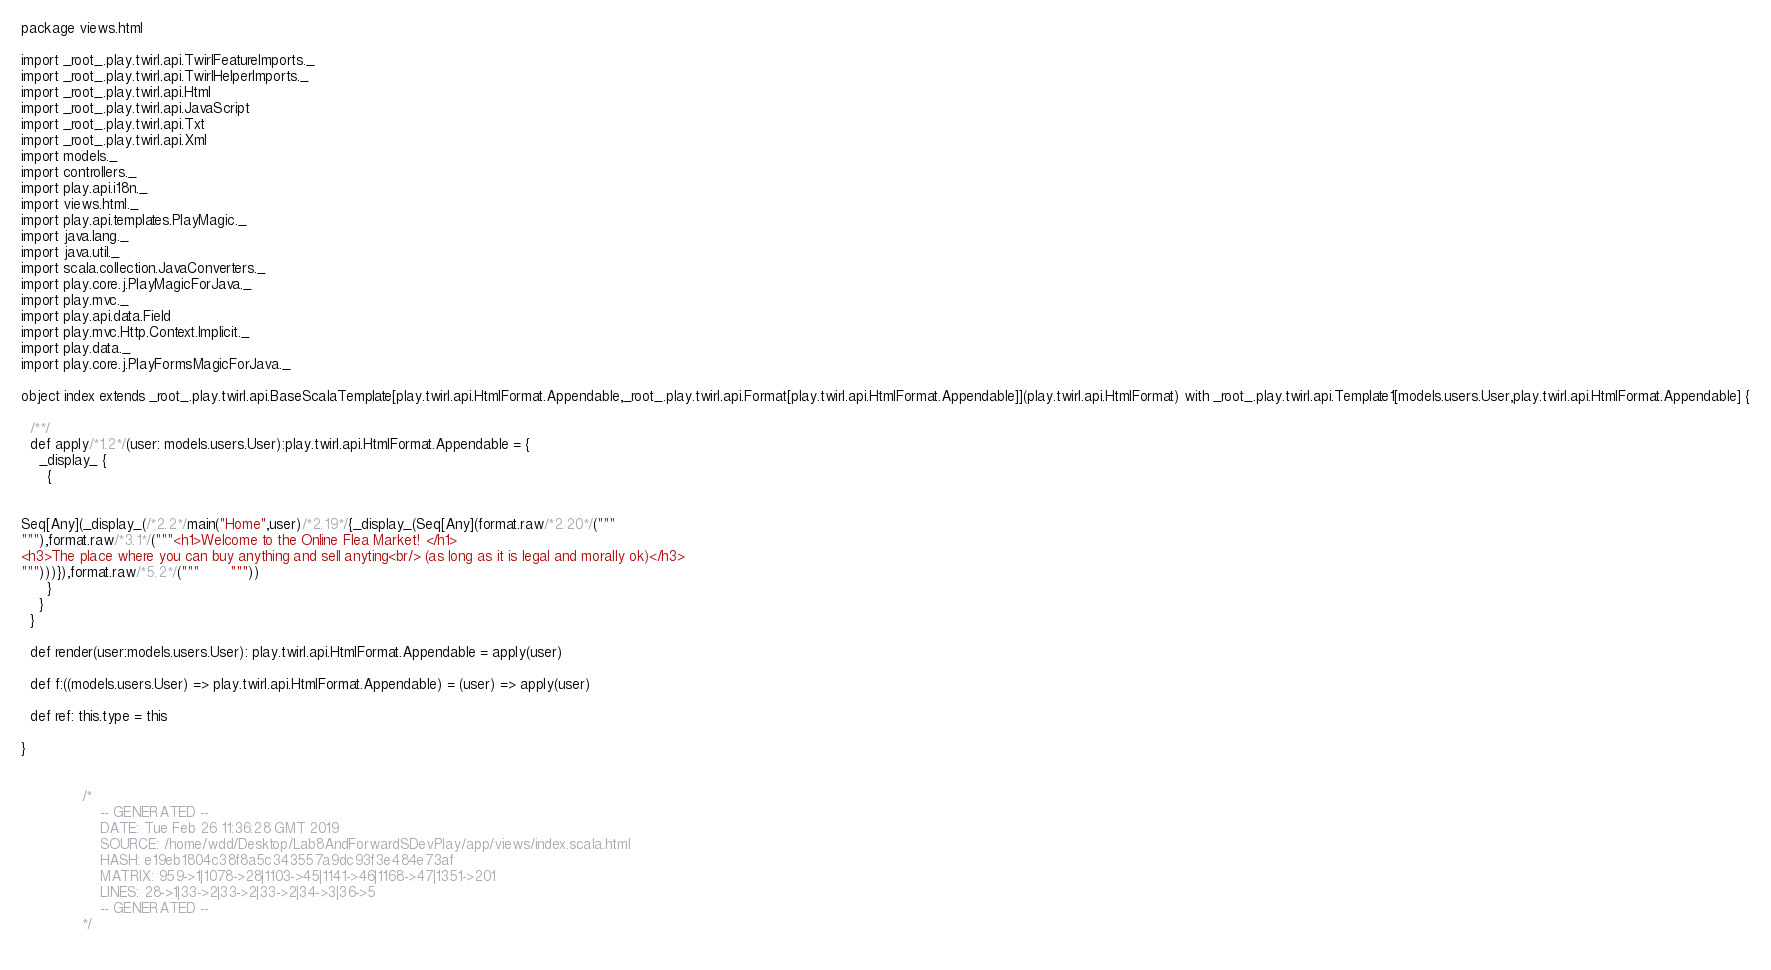Convert code to text. <code><loc_0><loc_0><loc_500><loc_500><_Scala_>
package views.html

import _root_.play.twirl.api.TwirlFeatureImports._
import _root_.play.twirl.api.TwirlHelperImports._
import _root_.play.twirl.api.Html
import _root_.play.twirl.api.JavaScript
import _root_.play.twirl.api.Txt
import _root_.play.twirl.api.Xml
import models._
import controllers._
import play.api.i18n._
import views.html._
import play.api.templates.PlayMagic._
import java.lang._
import java.util._
import scala.collection.JavaConverters._
import play.core.j.PlayMagicForJava._
import play.mvc._
import play.api.data.Field
import play.mvc.Http.Context.Implicit._
import play.data._
import play.core.j.PlayFormsMagicForJava._

object index extends _root_.play.twirl.api.BaseScalaTemplate[play.twirl.api.HtmlFormat.Appendable,_root_.play.twirl.api.Format[play.twirl.api.HtmlFormat.Appendable]](play.twirl.api.HtmlFormat) with _root_.play.twirl.api.Template1[models.users.User,play.twirl.api.HtmlFormat.Appendable] {

  /**/
  def apply/*1.2*/(user: models.users.User):play.twirl.api.HtmlFormat.Appendable = {
    _display_ {
      {


Seq[Any](_display_(/*2.2*/main("Home",user)/*2.19*/{_display_(Seq[Any](format.raw/*2.20*/("""
"""),format.raw/*3.1*/("""<h1>Welcome to the Online Flea Market! </h1>
<h3>The place where you can buy anything and sell anyting<br/> (as long as it is legal and morally ok)</h3>
""")))}),format.raw/*5.2*/("""		  """))
      }
    }
  }

  def render(user:models.users.User): play.twirl.api.HtmlFormat.Appendable = apply(user)

  def f:((models.users.User) => play.twirl.api.HtmlFormat.Appendable) = (user) => apply(user)

  def ref: this.type = this

}


              /*
                  -- GENERATED --
                  DATE: Tue Feb 26 11:36:28 GMT 2019
                  SOURCE: /home/wdd/Desktop/Lab8AndForwardSDevPlay/app/views/index.scala.html
                  HASH: e19eb1804c38f8a5c343557a9dc93f3e484e73af
                  MATRIX: 959->1|1078->28|1103->45|1141->46|1168->47|1351->201
                  LINES: 28->1|33->2|33->2|33->2|34->3|36->5
                  -- GENERATED --
              */
          </code> 